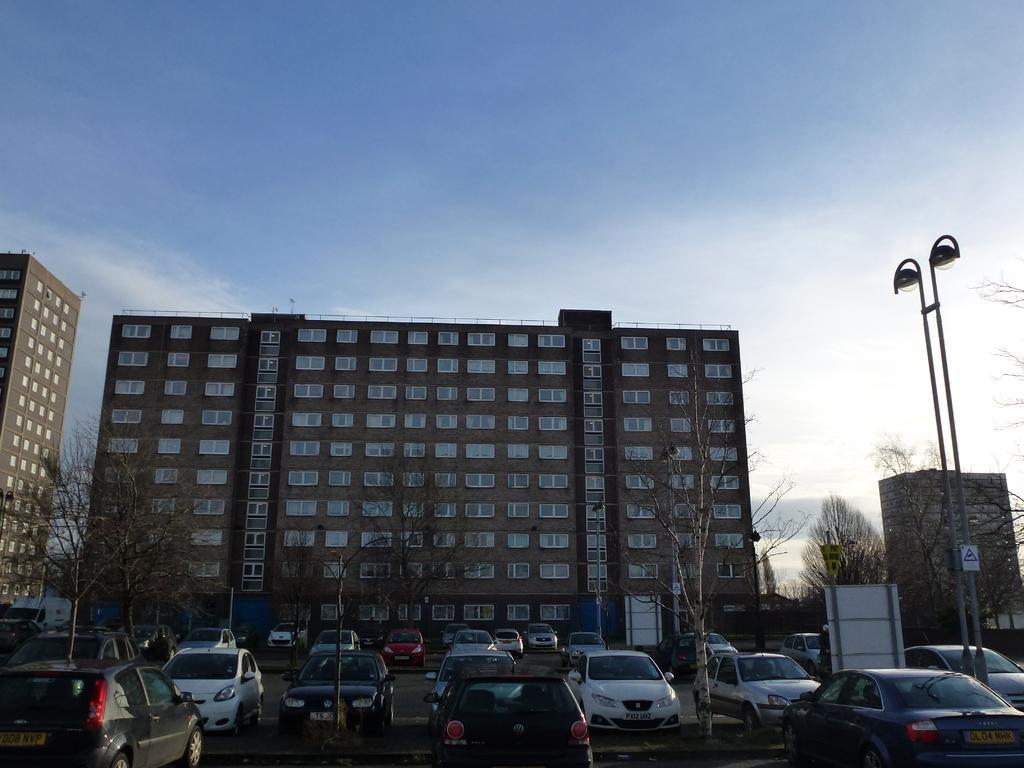Could you give a brief overview of what you see in this image? In this image we can see a group of buildings with windows. We can also see a group of trees, a board, street poles, a signboard, a group of cars placed on the ground and the sky which looks cloudy. 